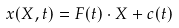Convert formula to latex. <formula><loc_0><loc_0><loc_500><loc_500>x ( X , t ) = { F } ( t ) \cdot X + c ( t )</formula> 